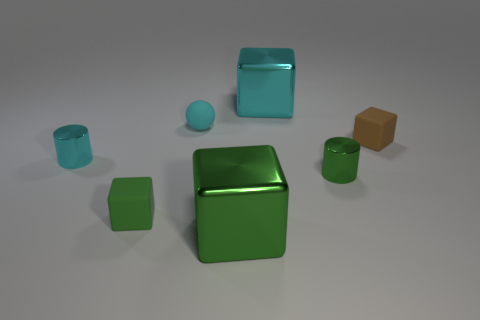There is a large object that is the same color as the small sphere; what is its material?
Give a very brief answer. Metal. Do the tiny cyan object on the left side of the tiny cyan rubber thing and the tiny cube that is left of the tiny green metal cylinder have the same material?
Provide a short and direct response. No. There is a tiny green thing that is left of the tiny shiny cylinder right of the big green metallic block; what is it made of?
Provide a short and direct response. Rubber. The green shiny object that is right of the large metallic object in front of the big shiny block that is behind the small cyan cylinder is what shape?
Provide a short and direct response. Cylinder. There is a large green thing that is the same shape as the small brown matte object; what is its material?
Your answer should be compact. Metal. What number of purple blocks are there?
Offer a terse response. 0. What is the shape of the big thing that is in front of the tiny green cylinder?
Keep it short and to the point. Cube. What color is the small metallic cylinder that is in front of the small metallic cylinder on the left side of the large metallic thing in front of the tiny brown matte block?
Offer a terse response. Green. What shape is the small green thing that is the same material as the cyan block?
Keep it short and to the point. Cylinder. Are there fewer small blocks than large cyan metal objects?
Make the answer very short. No. 